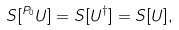Convert formula to latex. <formula><loc_0><loc_0><loc_500><loc_500>S [ ^ { P _ { 0 } } U ] = S [ U ^ { \dagger } ] = S [ U ] ,</formula> 